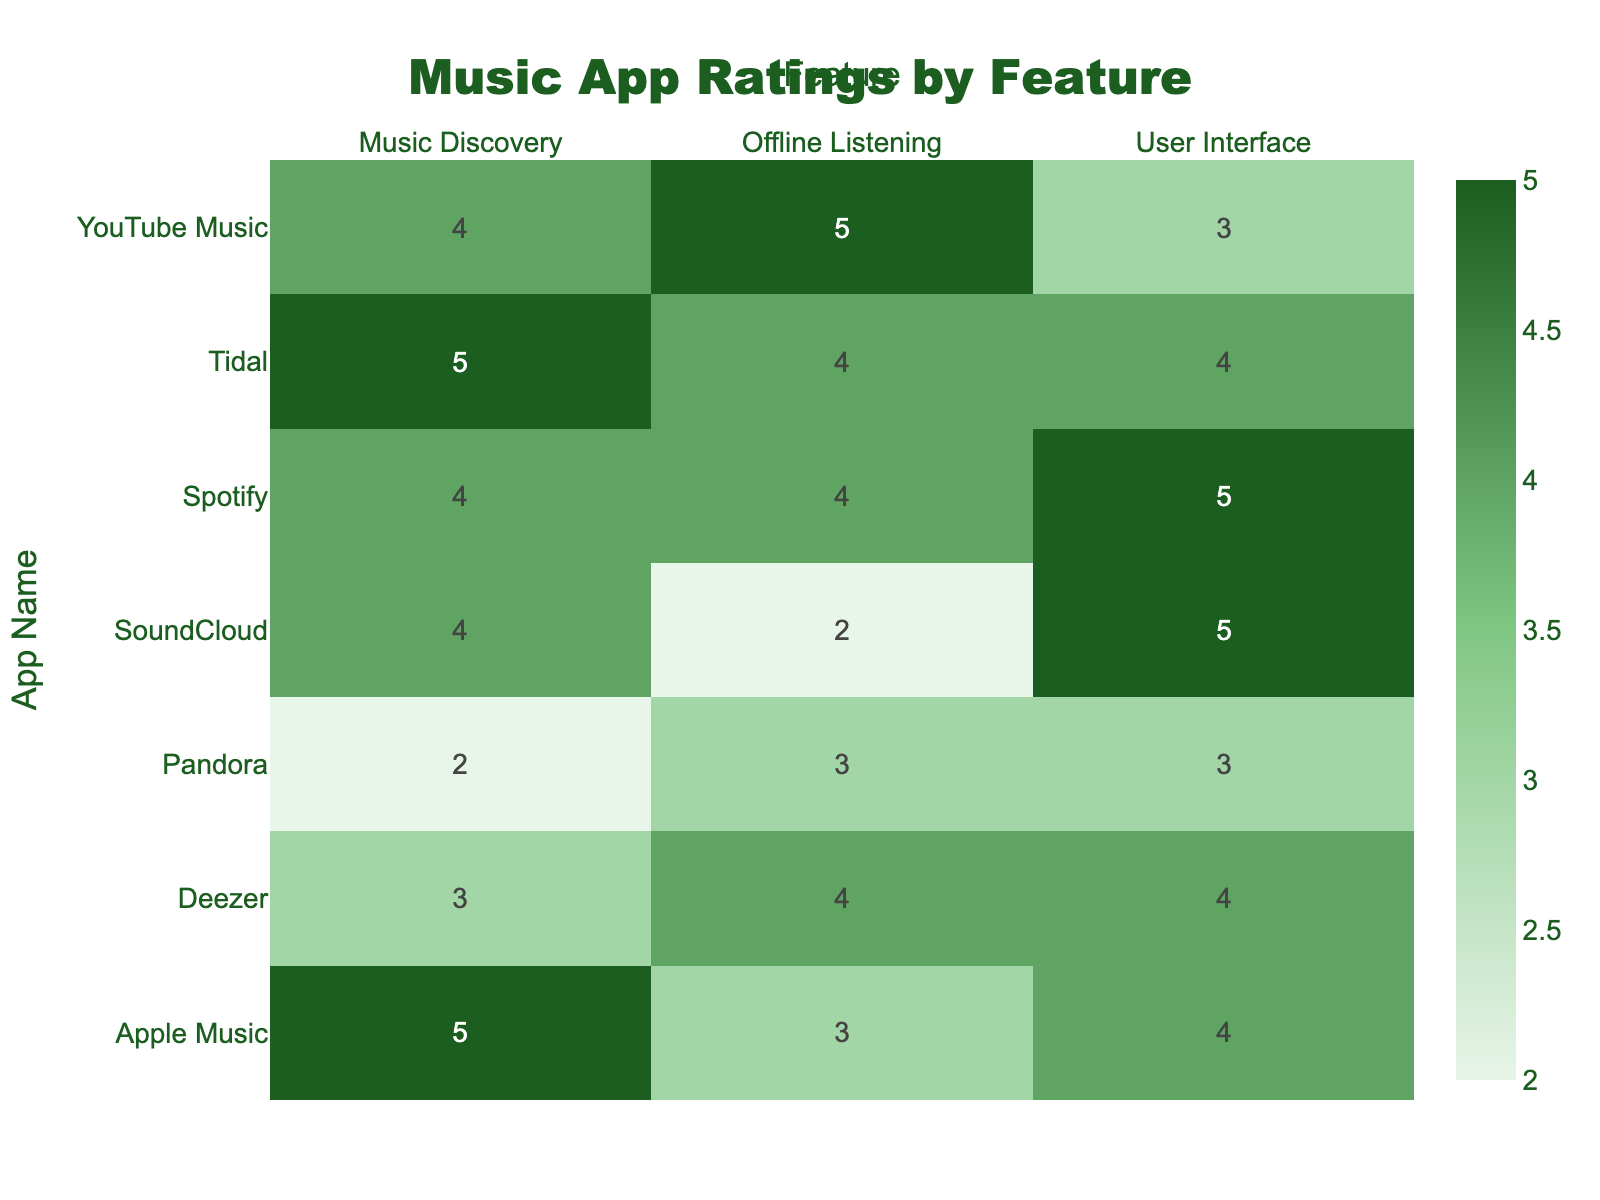What is the user rating for the User Interface of SoundCloud? The table shows that the rating for SoundCloud under the User Interface feature is 5.
Answer: 5 Which app received the highest rating for Music Discovery? By checking the Music Discovery ratings in the table, Apple Music and Tidal both received a rating of 5, which is the highest among all apps.
Answer: Apple Music and Tidal What is the average rating for Offline Listening across all apps? To calculate the average rating for Offline Listening, we take the ratings: 4 (Spotify) + 3 (Apple Music) + 5 (YouTube Music) + 4 (Tidal) + 3 (Pandora) + 2 (SoundCloud) + 4 (Deezer) = 25. There are 7 ratings in total, so the average is 25/7 ≈ 3.57, which rounds to 3.6.
Answer: 3.6 Did any app receive a rating of 2 for the Music Discovery feature? Looking at the Music Discovery ratings in the table, Pandora has a rating of 2, which confirms that there is at least one app that received this rating for that feature.
Answer: Yes What is the total rating for the User Interface across all apps? To find the total rating for User Interface, sum the ratings: 5 (Spotify) + 4 (Apple Music) + 3 (YouTube Music) + 4 (Tidal) + 3 (Pandora) + 5 (SoundCloud) + 4 (Deezer) = 28.
Answer: 28 Which two apps have the same rating for Offline Listening? From the table, YouTube Music and Tidal both have a rating of 4 for Offline Listening, indicating they share the same rating for this feature.
Answer: YouTube Music and Tidal What is the lowest rating given for the User Interface? The table shows that the User Interface ratings for YouTube Music and Pandora are both 3, making them the lowest ratings for this feature across all apps.
Answer: 3 Which app has the most balanced ratings across all three features (User Interface, Music Discovery, and Offline Listening)? Analyzing the ratings for each app, Apple Music has ratings of 4, 5, and 3 respectively, making it the most balanced compared to others with larger discrepancies.
Answer: Apple Music 